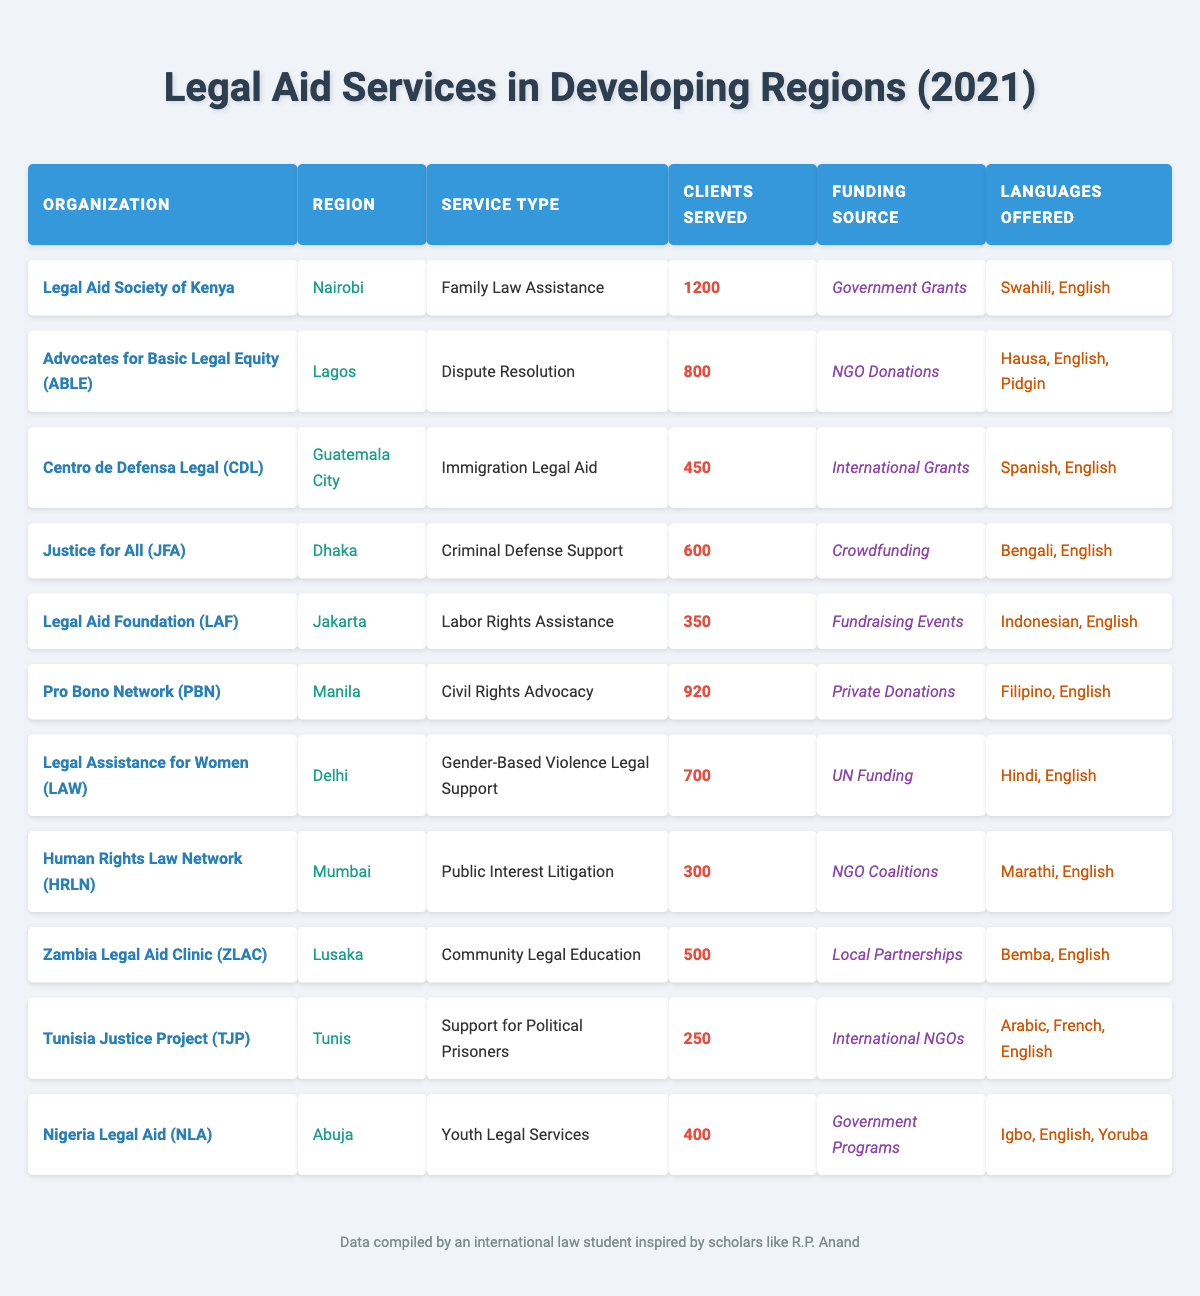What is the total number of clients served by all organizations listed? To find the total clients served, we add all the values in the "Clients Served" column. 1200 (Legal Aid Society of Kenya) + 800 (ABLE) + 450 (CDL) + 600 (JFA) + 350 (LAF) + 920 (PBN) + 700 (LAW) + 300 (HRLN) + 500 (ZLAC) + 250 (TJP) + 400 (NLA) =  5,820.
Answer: 5820 Which organization served the highest number of clients? Looking at the "Clients Served" column, Legal Aid Society of Kenya has the highest number at 1200.
Answer: Legal Aid Society of Kenya Did any organization receive funding from government sources? Yes, Legal Aid Society of Kenya and Nigeria Legal Aid both indicate "Government Grants" and "Government Programs" as their funding source.
Answer: Yes What is the average number of clients served per organization? To calculate the average, we divide the total number of clients (5820) by the total number of organizations (11). 5820 / 11 = 529.09. Rounding gives approximately 529.
Answer: Approximately 529 How many organizations provided legal services in the region of Africa? The African organizations are Legal Aid Society of Kenya (Nairobi), Advocates for Basic Legal Equity (Lagos), and Nigeria Legal Aid (Abuja). So, there are 3 organizations.
Answer: 3 Which region had the least number of clients served? By comparing the "Clients Served" for each region, Human Rights Law Network (Mumbai) served the least with 300 clients.
Answer: Mumbai What types of legal services were offered by the organizations based in Asia? The organizations based in Asia are Justice for All (Criminal Defense Support), Legal Assistance for Women (Gender-Based Violence Legal Support), Pro Bono Network (Civil Rights Advocacy), and Human Rights Law Network (Public Interest Litigation).
Answer: 4 services Is there any organization that serves clients in more than two languages? Yes, Advocates for Basic Legal Equity (ABLE) offers services in three languages: Hausa, English, and Pidgin.
Answer: Yes What funding sources were utilized by organizations offering Family Law Assistance? Only one organization, Legal Aid Society of Kenya, provided Family Law Assistance and their funding source is "Government Grants."
Answer: Government Grants If you combine the clients served by organizations in Latin America, what would be the total? Centro de Defensa Legal (CDL) served 450 clients in Guatemala City, the only Latin American organization listed, so the total is 450.
Answer: 450 Which organization focused on community legal education? Zambia Legal Aid Clinic (ZLAC) provided Community Legal Education services.
Answer: Zambia Legal Aid Clinic (ZLAC) 